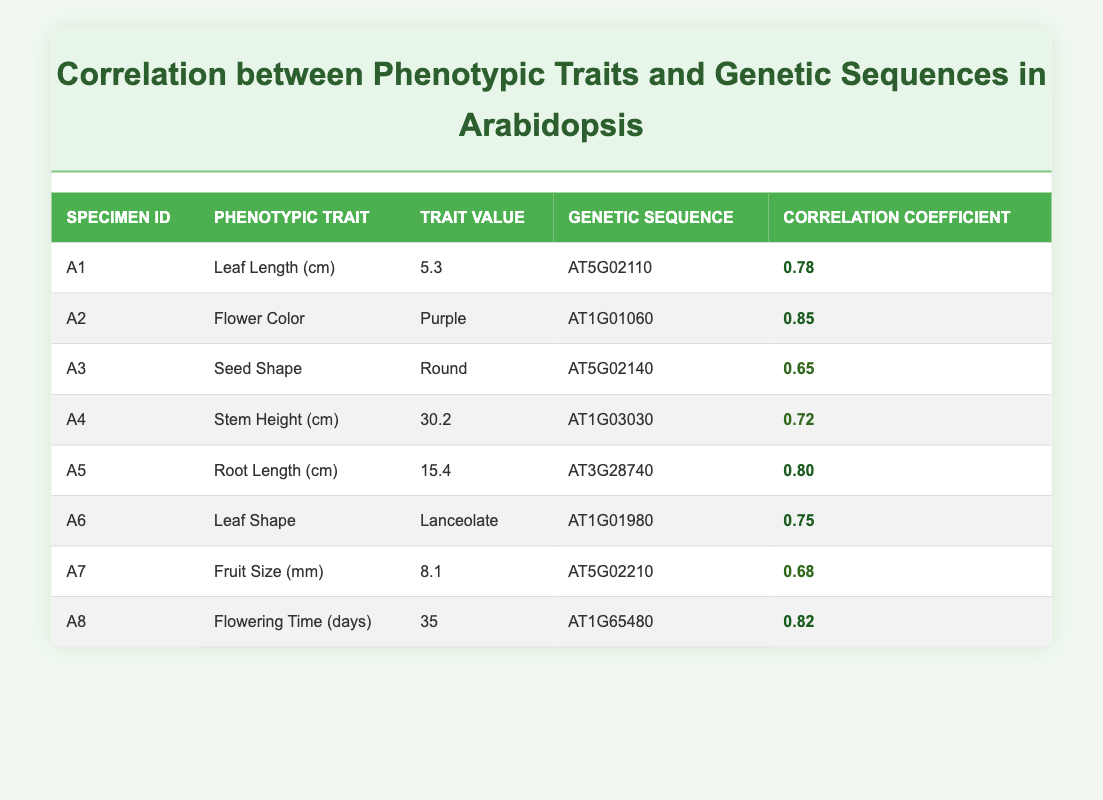What is the correlation coefficient for Flower Color? The correlation coefficient for Flower Color, which is associated with specimen A2, is 0.85 as indicated in the table.
Answer: 0.85 Which specimen has the highest correlation coefficient? By examining the correlation coefficients in the table, A2 has the highest value of 0.85.
Answer: A2 How many specimens have a correlation coefficient greater than 0.75? The specimens with coefficients greater than 0.75 are A2 (0.85), A5 (0.80), A8 (0.82), A1 (0.78), and A6 (0.75), totaling 5 specimens.
Answer: 5 What is the average correlation coefficient of the traits listed? The correlation coefficients are 0.78, 0.85, 0.65, 0.72, 0.80, 0.75, 0.68, and 0.82. The total sum is 0.78 + 0.85 + 0.65 + 0.72 + 0.80 + 0.75 + 0.68 + 0.82 = 5.55. Dividing by 8 (the number of specimens) gives an average of 5.55 / 8 = 0.69375.
Answer: 0.69 Is there any specimen with a correlation coefficient lower than 0.70? The table shows that specimen A3 has a correlation coefficient of 0.65, which is lower than 0.70.
Answer: Yes Which trait has a correlation coefficient closest to 0.70? Comparing the correlation coefficients, A4 (Stem Height with a coefficient of 0.72) is the closest to 0.70.
Answer: A4 What is the trait value associated with the genetic sequence AT1G03030? The genetic sequence AT1G03030 corresponds to the trait Stem Height, which has a value of 30.2 cm in the table.
Answer: 30.2 cm How does the correlation coefficient of Root Length compare to that of Seed Shape? The correlation coefficient for Root Length (A5) is 0.80, while for Seed Shape (A3) it is 0.65. Therefore, Root Length has a higher correlation coefficient than Seed Shape.
Answer: Higher What is the phenotypic trait with the lowest correlation coefficient? The lowest correlation coefficient is for Seed Shape (A3), which is 0.65 as noted in the table.
Answer: Seed Shape 